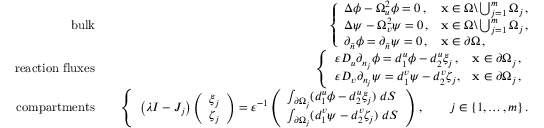<formula> <loc_0><loc_0><loc_500><loc_500>\begin{array} { r l r } { b u l k } & { \left \{ \begin{array} { l l } { \Delta \phi - \Omega _ { u } ^ { 2 } \phi = 0 \, , } & { { x } \in \Omega \ \bigcup _ { j = 1 } ^ { m } \Omega _ { j } \, , } \\ { \Delta \psi - \Omega _ { v } ^ { 2 } \psi = 0 \, , } & { { x } \in \Omega \ \bigcup _ { j = 1 } ^ { m } \Omega _ { j } \, , } \\ { \partial _ { \tilde { n } } \phi = \partial _ { \tilde { n } } \psi = 0 \, , } & { { x } \in \partial \Omega \, , } \end{array} } \\ { r e a c t i o n f l u x e s } & { \left \{ \begin{array} { l l } { \varepsilon D _ { u } \partial _ { n _ { j } } \phi = d _ { 1 } ^ { u } \phi - d _ { 2 } ^ { u } \xi _ { j } \, , } & { { x } \in \partial \Omega _ { j } \, , \, } \\ { \varepsilon D _ { v } \partial _ { n _ { j } } \psi = d _ { 1 } ^ { v } \psi - d _ { 2 } ^ { v } \zeta _ { j } , } & { { x } \in \partial \Omega _ { j } \, , } \end{array} } \\ { c o m p a r t m e n t s } & { \left \{ \begin{array} { l l } { \left ( \lambda I - J _ { j } \right ) \left ( \begin{array} { l } { \xi _ { j } } \\ { \zeta _ { j } } \end{array} \right ) = \varepsilon ^ { - 1 } \left ( \begin{array} { l } { \int _ { \partial \Omega _ { j } } ( d _ { 1 } ^ { u } \phi - d _ { 2 } ^ { u } \xi _ { j } ) \, d S } \\ { \int _ { \partial \Omega _ { j } } ( d _ { 1 } ^ { v } \psi - d _ { 2 } ^ { v } \zeta _ { j } ) \, d S } \end{array} \right ) \, , \quad j \in \{ { 1 , \dots , m \} } \, . } \end{array} } \end{array}</formula> 